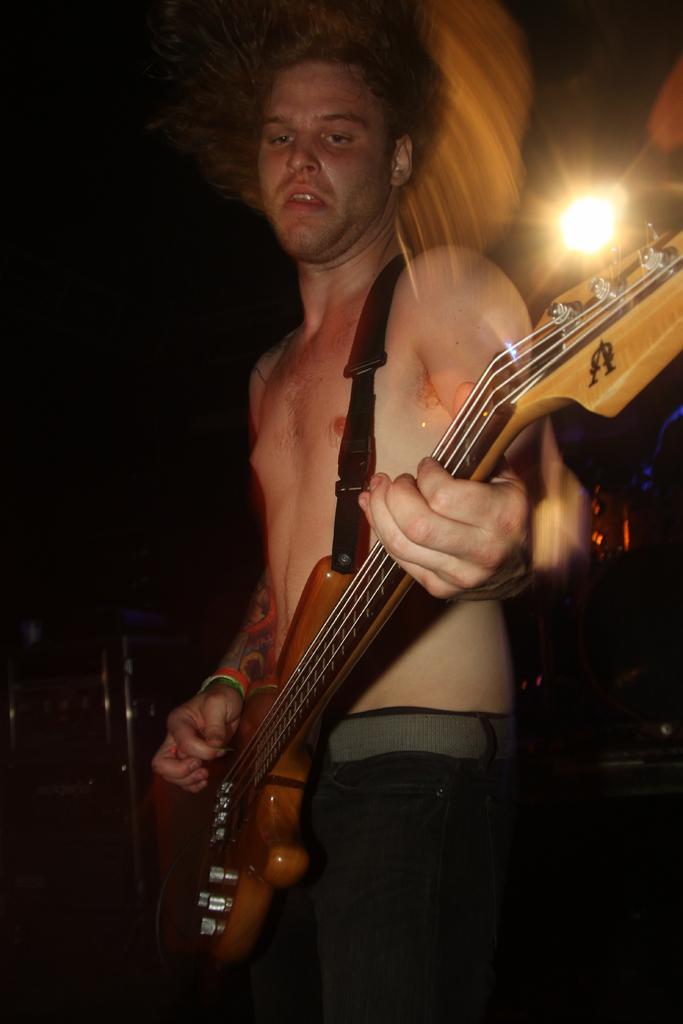How would you summarize this image in a sentence or two? This is a picture of a guy who is holding a guitar and playing it and behind him there is a light. 